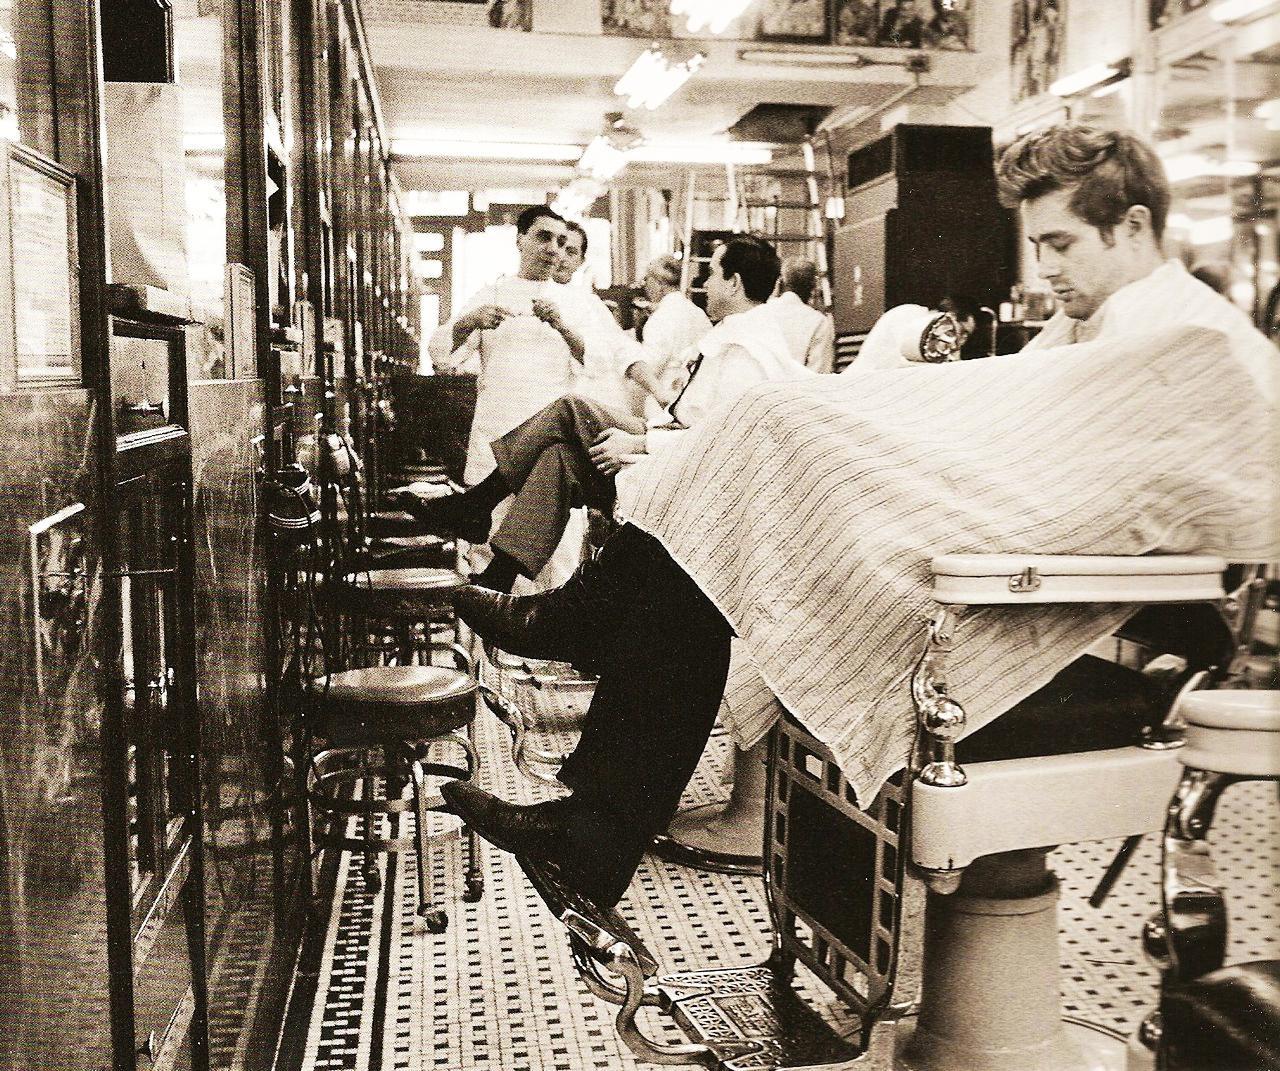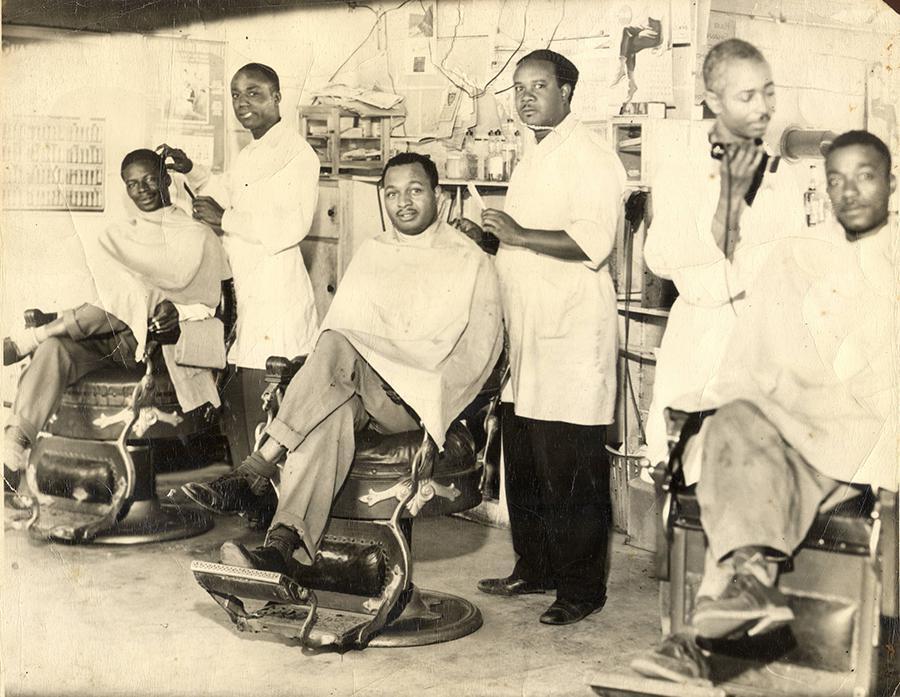The first image is the image on the left, the second image is the image on the right. For the images shown, is this caption "the picture i=on the left is in color" true? Answer yes or no. No. The first image is the image on the left, the second image is the image on the right. Examine the images to the left and right. Is the description "In each image, there is more than one person sitting down." accurate? Answer yes or no. Yes. 